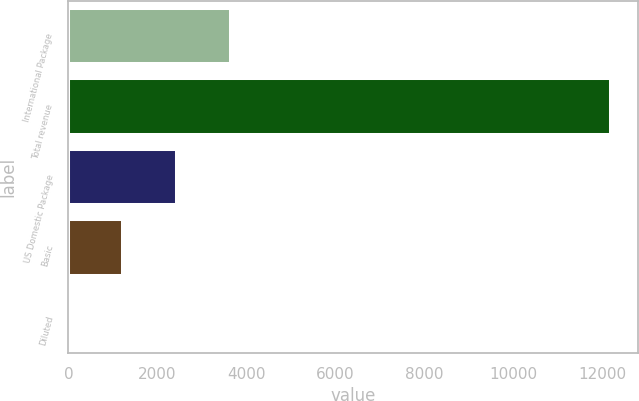<chart> <loc_0><loc_0><loc_500><loc_500><bar_chart><fcel>International Package<fcel>Total revenue<fcel>US Domestic Package<fcel>Basic<fcel>Diluted<nl><fcel>3658.29<fcel>12192<fcel>2439.19<fcel>1220.09<fcel>0.99<nl></chart> 